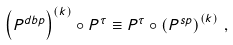<formula> <loc_0><loc_0><loc_500><loc_500>\left ( P ^ { d b p } \right ) ^ { \left ( k \right ) } \circ P ^ { \tau } \equiv P ^ { \tau } \circ \left ( P ^ { s p } \right ) ^ { \left ( k \right ) } \, ,</formula> 